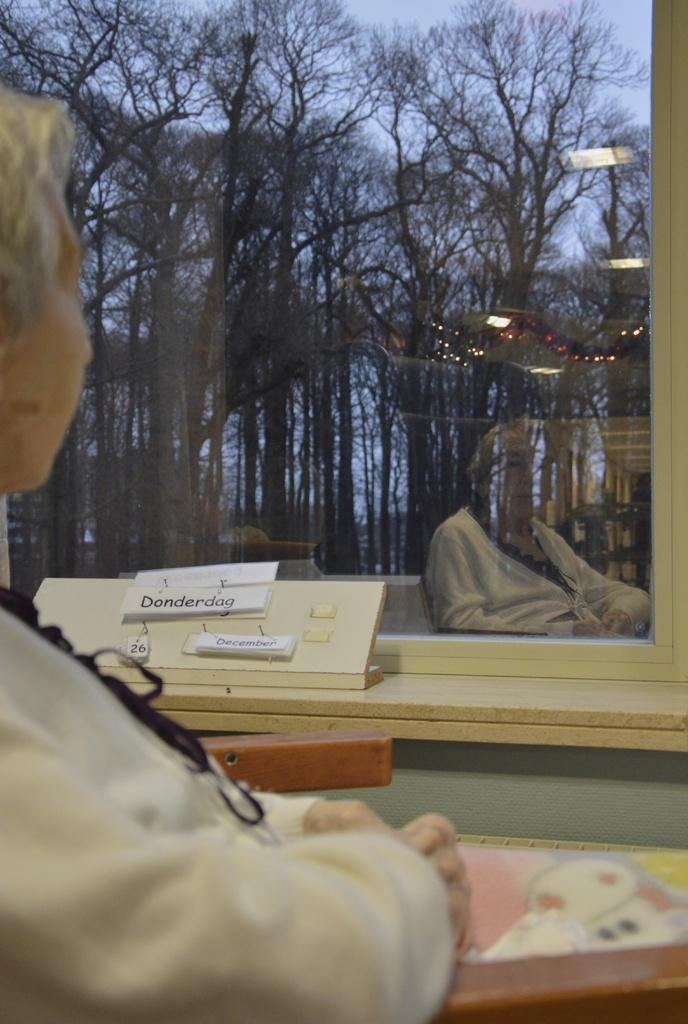What is the appearance of the woman in the image? The woman in the image has blond hair. What is the woman doing in the image? The woman is sitting in the image. Where is the woman located in relation to the window? The woman is in front of a window in the image. What can be seen outside the window? Trees are visible behind the window, and the sky is visible above the trees. What type of cake is the woman holding in the image? There is no cake present in the image; the woman is sitting in front of a window with trees and sky visible behind it. 